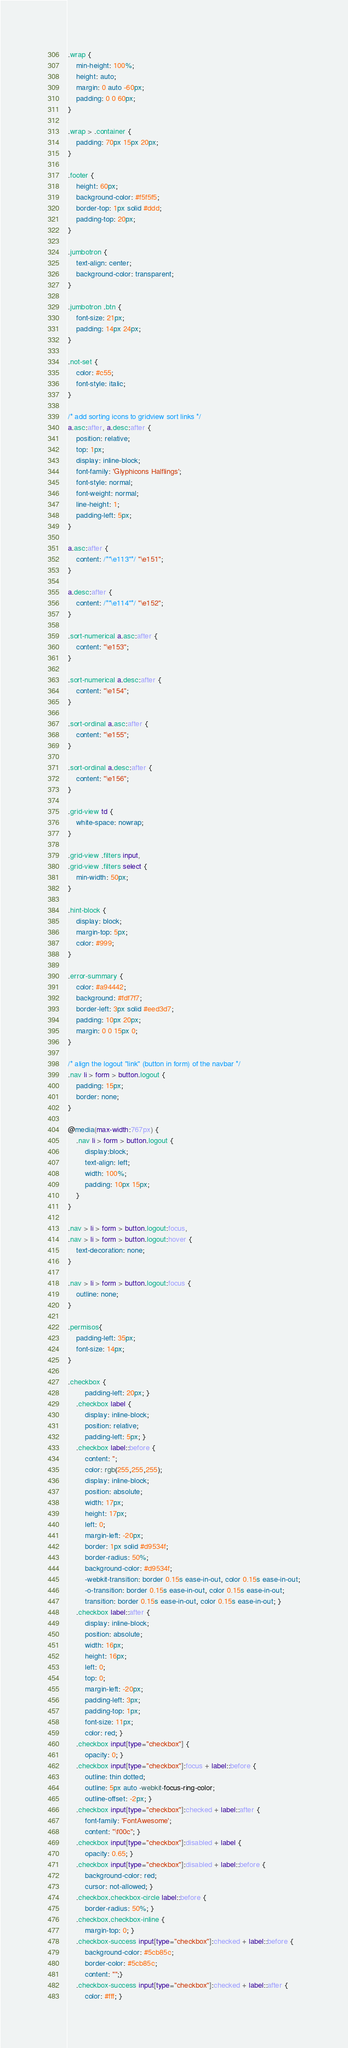Convert code to text. <code><loc_0><loc_0><loc_500><loc_500><_CSS_>
.wrap {
    min-height: 100%;
    height: auto;
    margin: 0 auto -60px;
    padding: 0 0 60px;
}

.wrap > .container {
    padding: 70px 15px 20px;
}

.footer {
    height: 60px;
    background-color: #f5f5f5;
    border-top: 1px solid #ddd;
    padding-top: 20px;
}

.jumbotron {
    text-align: center;
    background-color: transparent;
}

.jumbotron .btn {
    font-size: 21px;
    padding: 14px 24px;
}

.not-set {
    color: #c55;
    font-style: italic;
}

/* add sorting icons to gridview sort links */
a.asc:after, a.desc:after {
    position: relative;
    top: 1px;
    display: inline-block;
    font-family: 'Glyphicons Halflings';
    font-style: normal;
    font-weight: normal;
    line-height: 1;
    padding-left: 5px;
}

a.asc:after {
    content: /*"\e113"*/ "\e151";
}

a.desc:after {
    content: /*"\e114"*/ "\e152";
}

.sort-numerical a.asc:after {
    content: "\e153";
}

.sort-numerical a.desc:after {
    content: "\e154";
}

.sort-ordinal a.asc:after {
    content: "\e155";
}

.sort-ordinal a.desc:after {
    content: "\e156";
}

.grid-view td {
    white-space: nowrap;
}

.grid-view .filters input,
.grid-view .filters select {
    min-width: 50px;
}

.hint-block {
    display: block;
    margin-top: 5px;
    color: #999;
}

.error-summary {
    color: #a94442;
    background: #fdf7f7;
    border-left: 3px solid #eed3d7;
    padding: 10px 20px;
    margin: 0 0 15px 0;
}

/* align the logout "link" (button in form) of the navbar */
.nav li > form > button.logout {
    padding: 15px;
    border: none;
}

@media(max-width:767px) {
    .nav li > form > button.logout {
        display:block;
        text-align: left;
        width: 100%;
        padding: 10px 15px;
    }
}

.nav > li > form > button.logout:focus,
.nav > li > form > button.logout:hover {
    text-decoration: none;
}

.nav > li > form > button.logout:focus {
    outline: none;
}

.permisos{
    padding-left: 35px;
    font-size: 14px;
}

.checkbox {
        padding-left: 20px; }
    .checkbox label {
        display: inline-block;
        position: relative;
        padding-left: 5px; }
    .checkbox label::before {
        content: '';
        color: rgb(255,255,255);
        display: inline-block;
        position: absolute;
        width: 17px;
        height: 17px;
        left: 0;
        margin-left: -20px;
        border: 1px solid #d9534f;
        border-radius: 50%;
        background-color: #d9534f;
        -webkit-transition: border 0.15s ease-in-out, color 0.15s ease-in-out;
        -o-transition: border 0.15s ease-in-out, color 0.15s ease-in-out;
        transition: border 0.15s ease-in-out, color 0.15s ease-in-out; }
    .checkbox label::after {
        display: inline-block;
        position: absolute;
        width: 16px;
        height: 16px;
        left: 0;
        top: 0;
        margin-left: -20px;
        padding-left: 3px;
        padding-top: 1px;
        font-size: 11px;
        color: red; }
    .checkbox input[type="checkbox"] {
        opacity: 0; }
    .checkbox input[type="checkbox"]:focus + label::before {
        outline: thin dotted;
        outline: 5px auto -webkit-focus-ring-color;
        outline-offset: -2px; }
    .checkbox input[type="checkbox"]:checked + label::after {
        font-family: 'FontAwesome';
        content: "\f00c"; }
    .checkbox input[type="checkbox"]:disabled + label {
        opacity: 0.65; }
    .checkbox input[type="checkbox"]:disabled + label::before {    
        background-color: red;
        cursor: not-allowed; }
    .checkbox.checkbox-circle label::before {
        border-radius: 50%; }
    .checkbox.checkbox-inline {
        margin-top: 0; }
    .checkbox-success input[type="checkbox"]:checked + label::before {
        background-color: #5cb85c;
        border-color: #5cb85c;
        content: "";}
    .checkbox-success input[type="checkbox"]:checked + label::after {
        color: #fff; }
</code> 